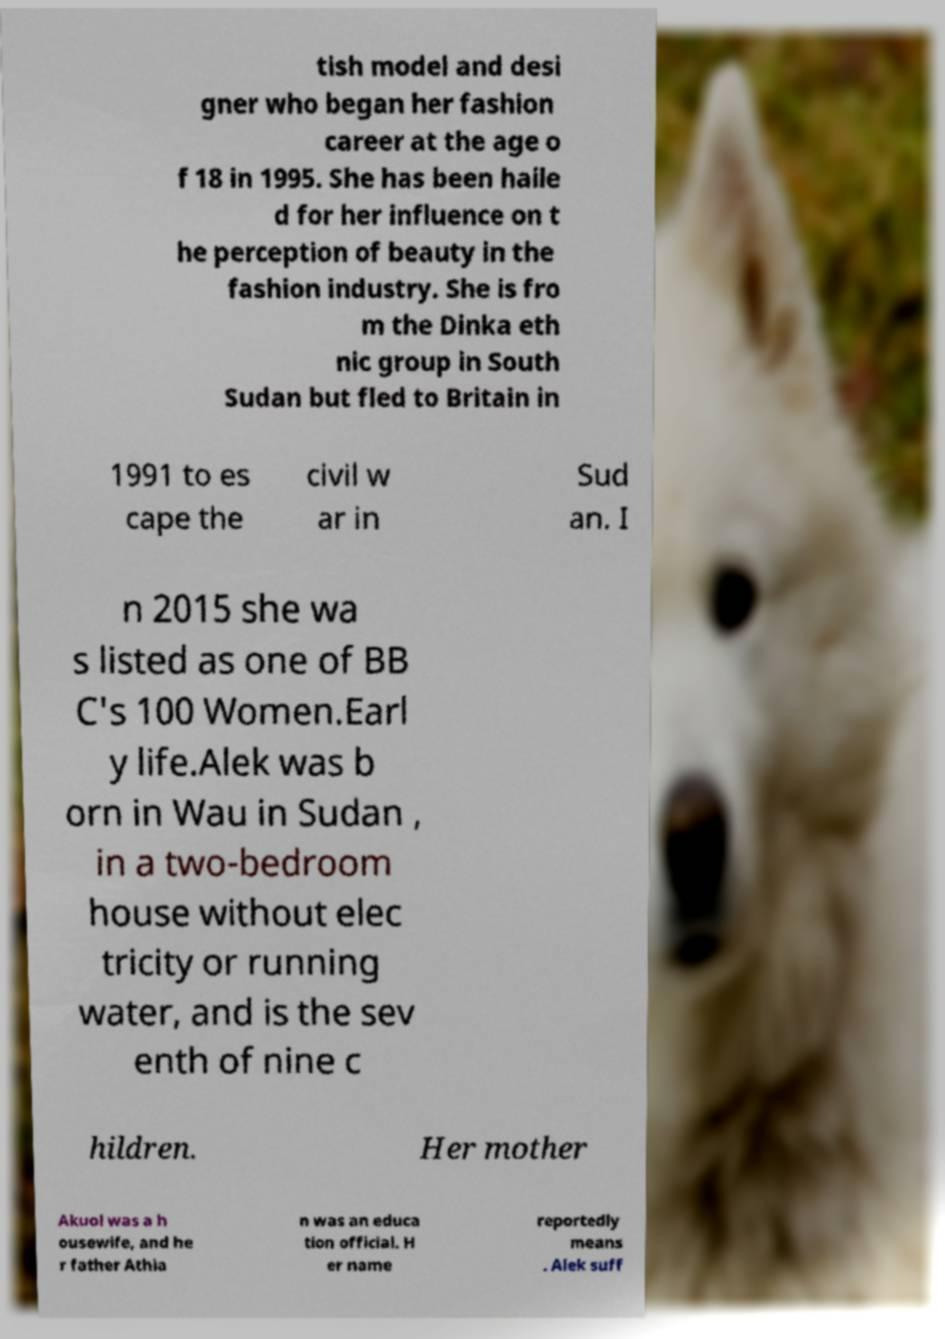What messages or text are displayed in this image? I need them in a readable, typed format. tish model and desi gner who began her fashion career at the age o f 18 in 1995. She has been haile d for her influence on t he perception of beauty in the fashion industry. She is fro m the Dinka eth nic group in South Sudan but fled to Britain in 1991 to es cape the civil w ar in Sud an. I n 2015 she wa s listed as one of BB C's 100 Women.Earl y life.Alek was b orn in Wau in Sudan , in a two-bedroom house without elec tricity or running water, and is the sev enth of nine c hildren. Her mother Akuol was a h ousewife, and he r father Athia n was an educa tion official. H er name reportedly means . Alek suff 